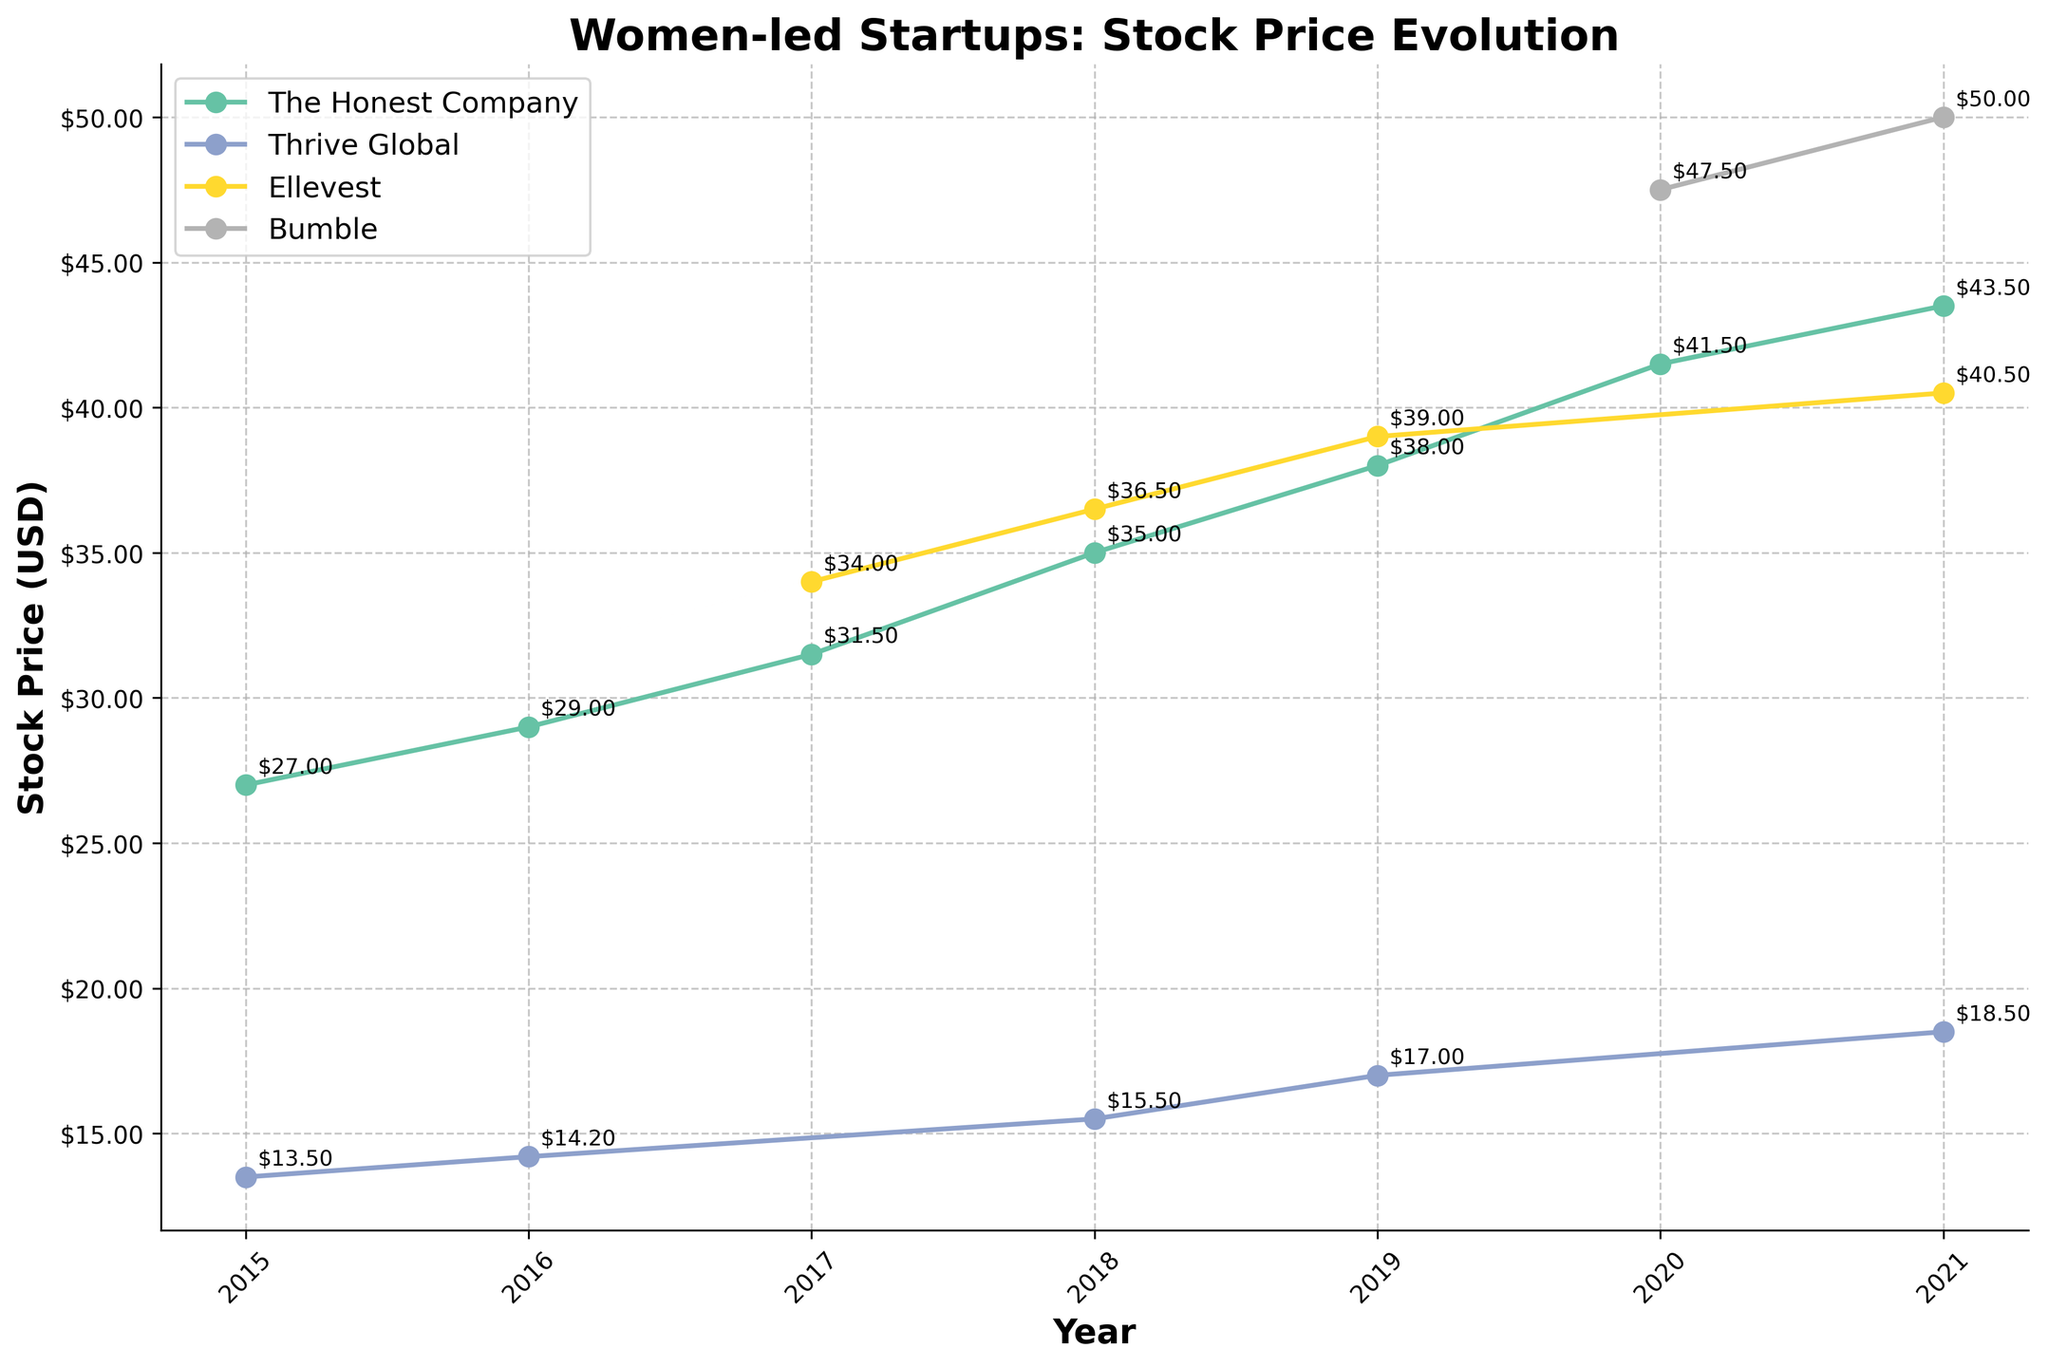What is the title of the plot? The title is located at the top of the figure, it often summarizes what the figure is about. The title in this plot reads "Women-led Startups: Stock Price Evolution".
Answer: Women-led Startups: Stock Price Evolution Which company had the highest stock price at the end of 2021? By looking at the stock price points for each company in 2021, we can see that Bumble had the highest stock price of $50.00 at year-end.
Answer: Bumble How did The Honest Company's stock price change from 2015 to 2021? We look at the stock prices for The Honest Company in 2015 and 2021. In 2015, it was $27.00, and in 2021, it was $43.50. So, the change is $43.50 - $27.00 = $16.50.
Answer: $16.50 Which company showed the greatest overall increase in stock price from the first year of their data to 2021? By checking each company's initial and 2021 stock prices, we can see that Ellevest started at $32.50 in 2017 and reached $40.50 in 2021, Bumble started at $45.00 in 2020 and reached $50.00 in 2021, and Thrive Global started at $13.00 in 2015 and reached $18.50 in 2021—a rise of $5.50. Bumble has the highest increase ($5.00, from $45.00 to $50.00) compared to other companies.
Answer: Bumble Which year did Ellevest enter the dataset, and what was their stock price at the end of that year? By examining the years listed for Ellevest, we find that they first appear in 2017, and we check the stock price noted in 2017 as $34.00.
Answer: 2017, $34.00 What was the average year-end stock price for The Honest Company from 2015 to 2021? Sum the year-end stock prices for The Honest Company from 2015 to 2021 and divide by the number of years. The prices are $27.00, $29.00, $31.50, $35.00, $38.00, $41.50, $43.50. The average is calculated as (27+29+31.5+35+38+41.5+43.5) / 7 = 35.07.
Answer: $35.07 Compare the year-end stock price trend of Thrive Global and Ellevest from 2017 to 2021. Which company had a steeper growth? By observing the stock price points over the years from 2017 to 2021, Thrive Global's prices were $14.20 in 2017 to $18.50 in 2021. Ellevest's prices went from $34.00 in 2017 to $40.50 in 2021. The absolute growth for Thrive Global is $4.30, and for Ellevest, it is $6.50, indicating Ellevest had steeper growth.
Answer: Ellevest 